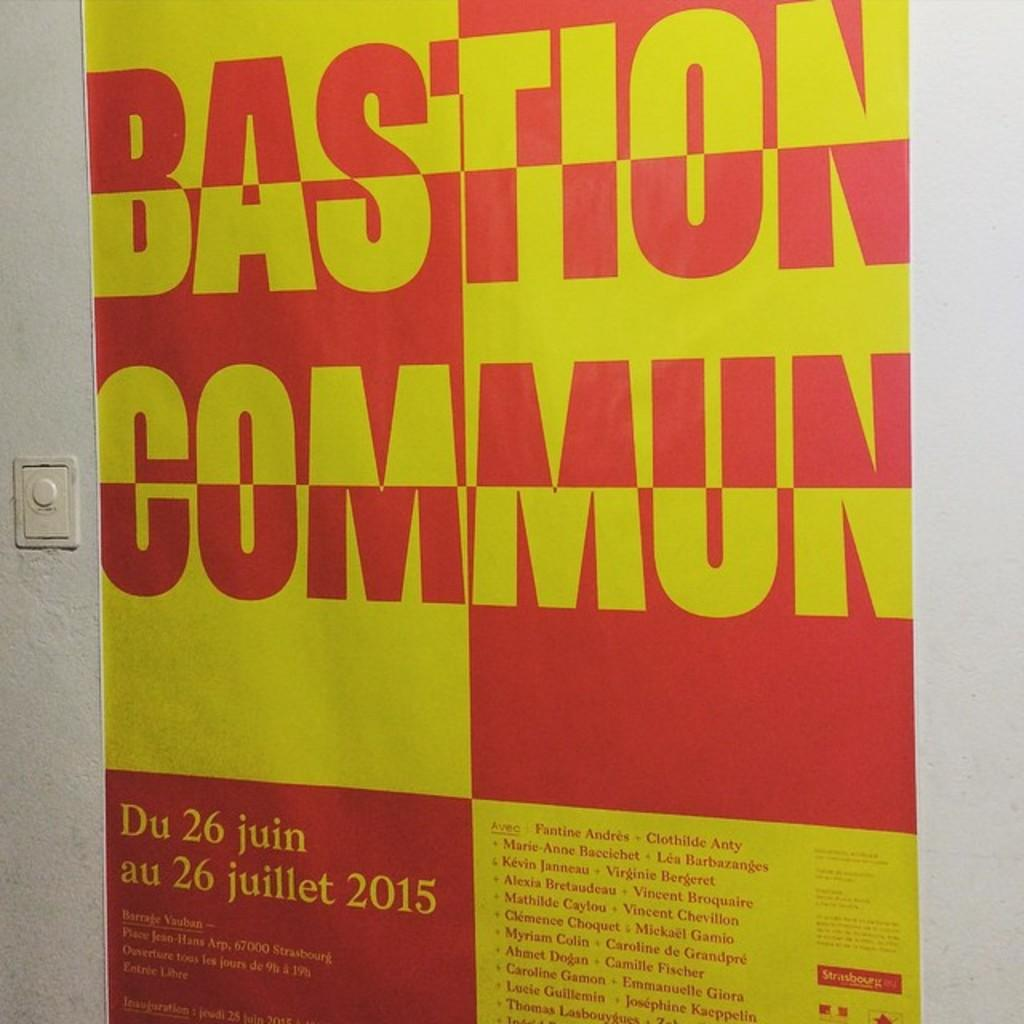What is hanging on the wall in the image? There is a banner on the wall in the image. What is written or displayed on the banner? The banner contains text. Can you play a note on the can in the image? There is no can present in the image, so it is not possible to play a note on it. 